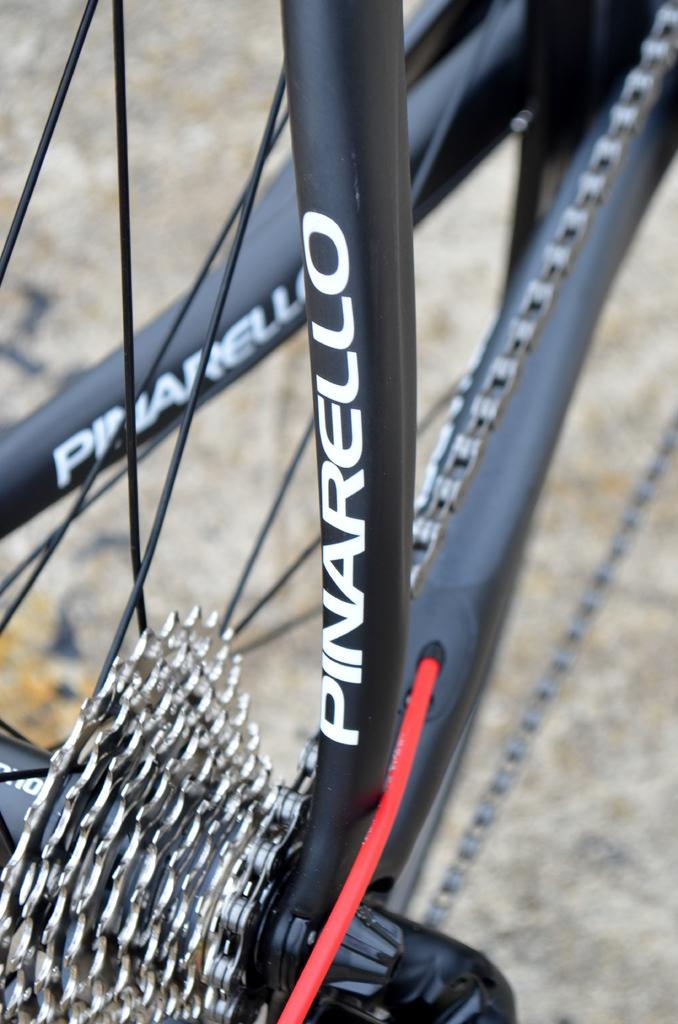What color is the bicycle frame in the image? The bicycle frame in the image is black. What feature does the bicycle frame have? The bicycle frame has gears. What can be seen beneath the bicycle frame in the image? There is a ground visible in the image. What type of bun is being used as a handlebar grip on the bicycle in the image? There is no bun present on the bicycle in the image; it is a regular bicycle with handlebars and no baked goods. 